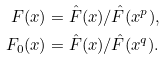<formula> <loc_0><loc_0><loc_500><loc_500>F ( x ) & = \hat { F } ( x ) / \hat { F } ( x ^ { p } ) , \\ F _ { 0 } ( x ) & = \hat { F } ( x ) / \hat { F } ( x ^ { q } ) .</formula> 